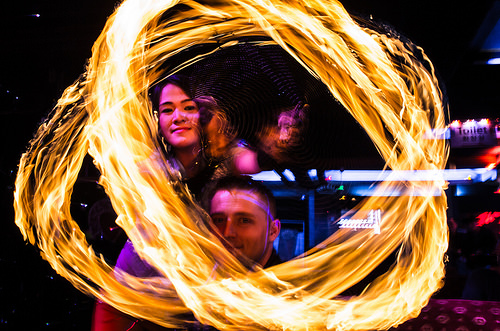<image>
Is there a man in the fire ring? Yes. The man is contained within or inside the fire ring, showing a containment relationship. 